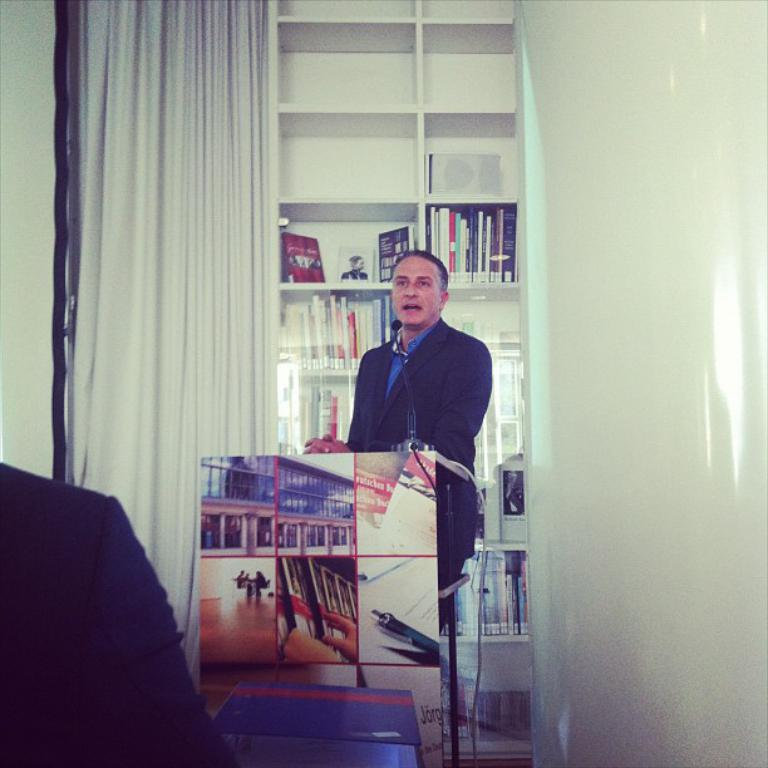What is the man in the image doing? The man is talking on the microphone. What object is present in front of the man? There is a podium in the image. What can be seen in the background of the image? There is a wall, a rack, books, and a curtain in the background of the image. What type of bubble can be seen floating in the image? There is no bubble present in the image. Is the weather in the image sunny or cloudy? The provided facts do not mention the weather, so it cannot be determined from the image. 